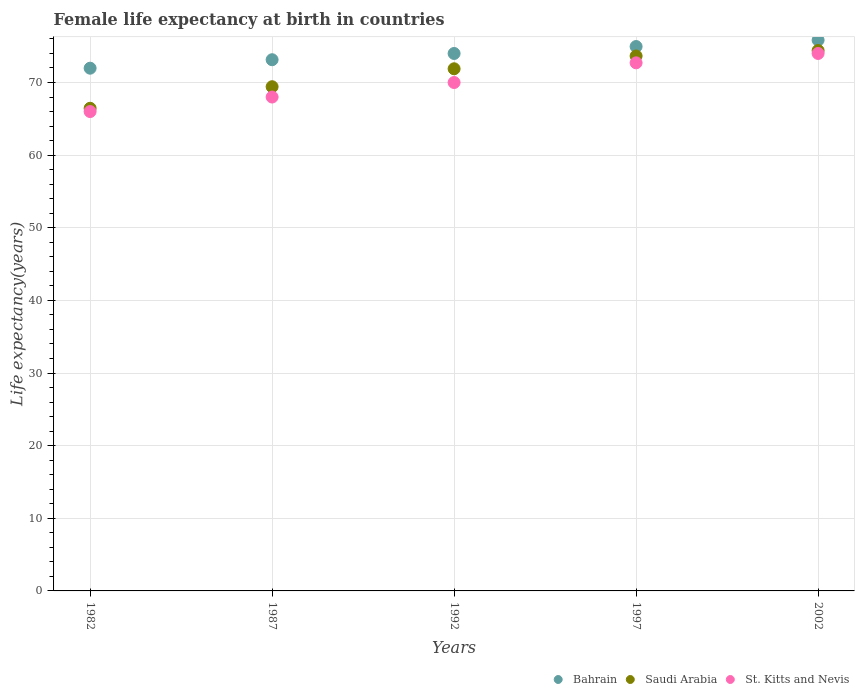How many different coloured dotlines are there?
Your answer should be compact. 3. Is the number of dotlines equal to the number of legend labels?
Your answer should be very brief. Yes. What is the female life expectancy at birth in St. Kitts and Nevis in 1982?
Your answer should be compact. 66. Across all years, what is the maximum female life expectancy at birth in Saudi Arabia?
Give a very brief answer. 74.41. Across all years, what is the minimum female life expectancy at birth in Bahrain?
Ensure brevity in your answer.  71.97. In which year was the female life expectancy at birth in Saudi Arabia minimum?
Your answer should be very brief. 1982. What is the total female life expectancy at birth in Saudi Arabia in the graph?
Provide a succinct answer. 355.82. What is the difference between the female life expectancy at birth in St. Kitts and Nevis in 1982 and that in 2002?
Provide a short and direct response. -8. What is the difference between the female life expectancy at birth in Bahrain in 1997 and the female life expectancy at birth in St. Kitts and Nevis in 1987?
Your answer should be compact. 6.95. What is the average female life expectancy at birth in St. Kitts and Nevis per year?
Provide a succinct answer. 70.14. In the year 1982, what is the difference between the female life expectancy at birth in Bahrain and female life expectancy at birth in St. Kitts and Nevis?
Your response must be concise. 5.97. In how many years, is the female life expectancy at birth in Bahrain greater than 52 years?
Your answer should be very brief. 5. What is the ratio of the female life expectancy at birth in Bahrain in 1982 to that in 1987?
Offer a terse response. 0.98. Is the difference between the female life expectancy at birth in Bahrain in 1992 and 1997 greater than the difference between the female life expectancy at birth in St. Kitts and Nevis in 1992 and 1997?
Make the answer very short. Yes. What is the difference between the highest and the second highest female life expectancy at birth in St. Kitts and Nevis?
Your answer should be very brief. 1.29. What is the difference between the highest and the lowest female life expectancy at birth in Bahrain?
Provide a short and direct response. 3.86. Is the sum of the female life expectancy at birth in St. Kitts and Nevis in 1992 and 2002 greater than the maximum female life expectancy at birth in Saudi Arabia across all years?
Offer a terse response. Yes. Is it the case that in every year, the sum of the female life expectancy at birth in Bahrain and female life expectancy at birth in Saudi Arabia  is greater than the female life expectancy at birth in St. Kitts and Nevis?
Keep it short and to the point. Yes. Does the female life expectancy at birth in Bahrain monotonically increase over the years?
Give a very brief answer. Yes. What is the difference between two consecutive major ticks on the Y-axis?
Your answer should be very brief. 10. Are the values on the major ticks of Y-axis written in scientific E-notation?
Your answer should be compact. No. Does the graph contain any zero values?
Ensure brevity in your answer.  No. Where does the legend appear in the graph?
Offer a very short reply. Bottom right. What is the title of the graph?
Make the answer very short. Female life expectancy at birth in countries. What is the label or title of the Y-axis?
Provide a succinct answer. Life expectancy(years). What is the Life expectancy(years) of Bahrain in 1982?
Ensure brevity in your answer.  71.97. What is the Life expectancy(years) of Saudi Arabia in 1982?
Provide a short and direct response. 66.45. What is the Life expectancy(years) in St. Kitts and Nevis in 1982?
Offer a very short reply. 66. What is the Life expectancy(years) in Bahrain in 1987?
Offer a very short reply. 73.14. What is the Life expectancy(years) of Saudi Arabia in 1987?
Your response must be concise. 69.42. What is the Life expectancy(years) in Bahrain in 1992?
Your answer should be compact. 74. What is the Life expectancy(years) in Saudi Arabia in 1992?
Your answer should be very brief. 71.89. What is the Life expectancy(years) of Bahrain in 1997?
Offer a very short reply. 74.95. What is the Life expectancy(years) of Saudi Arabia in 1997?
Provide a succinct answer. 73.65. What is the Life expectancy(years) of St. Kitts and Nevis in 1997?
Provide a short and direct response. 72.71. What is the Life expectancy(years) of Bahrain in 2002?
Your response must be concise. 75.83. What is the Life expectancy(years) of Saudi Arabia in 2002?
Ensure brevity in your answer.  74.41. What is the Life expectancy(years) of St. Kitts and Nevis in 2002?
Your response must be concise. 74. Across all years, what is the maximum Life expectancy(years) in Bahrain?
Your answer should be very brief. 75.83. Across all years, what is the maximum Life expectancy(years) in Saudi Arabia?
Give a very brief answer. 74.41. Across all years, what is the maximum Life expectancy(years) in St. Kitts and Nevis?
Your answer should be compact. 74. Across all years, what is the minimum Life expectancy(years) in Bahrain?
Your response must be concise. 71.97. Across all years, what is the minimum Life expectancy(years) in Saudi Arabia?
Offer a very short reply. 66.45. What is the total Life expectancy(years) in Bahrain in the graph?
Ensure brevity in your answer.  369.89. What is the total Life expectancy(years) in Saudi Arabia in the graph?
Offer a terse response. 355.82. What is the total Life expectancy(years) in St. Kitts and Nevis in the graph?
Your answer should be compact. 350.71. What is the difference between the Life expectancy(years) of Bahrain in 1982 and that in 1987?
Give a very brief answer. -1.17. What is the difference between the Life expectancy(years) in Saudi Arabia in 1982 and that in 1987?
Provide a short and direct response. -2.97. What is the difference between the Life expectancy(years) of St. Kitts and Nevis in 1982 and that in 1987?
Provide a succinct answer. -2. What is the difference between the Life expectancy(years) of Bahrain in 1982 and that in 1992?
Provide a short and direct response. -2.03. What is the difference between the Life expectancy(years) of Saudi Arabia in 1982 and that in 1992?
Ensure brevity in your answer.  -5.44. What is the difference between the Life expectancy(years) of Bahrain in 1982 and that in 1997?
Provide a short and direct response. -2.98. What is the difference between the Life expectancy(years) in Saudi Arabia in 1982 and that in 1997?
Give a very brief answer. -7.2. What is the difference between the Life expectancy(years) in St. Kitts and Nevis in 1982 and that in 1997?
Your answer should be compact. -6.71. What is the difference between the Life expectancy(years) in Bahrain in 1982 and that in 2002?
Make the answer very short. -3.86. What is the difference between the Life expectancy(years) in Saudi Arabia in 1982 and that in 2002?
Offer a very short reply. -7.95. What is the difference between the Life expectancy(years) in St. Kitts and Nevis in 1982 and that in 2002?
Make the answer very short. -8. What is the difference between the Life expectancy(years) in Bahrain in 1987 and that in 1992?
Provide a succinct answer. -0.86. What is the difference between the Life expectancy(years) in Saudi Arabia in 1987 and that in 1992?
Ensure brevity in your answer.  -2.47. What is the difference between the Life expectancy(years) of Bahrain in 1987 and that in 1997?
Offer a very short reply. -1.82. What is the difference between the Life expectancy(years) of Saudi Arabia in 1987 and that in 1997?
Your answer should be compact. -4.23. What is the difference between the Life expectancy(years) of St. Kitts and Nevis in 1987 and that in 1997?
Ensure brevity in your answer.  -4.71. What is the difference between the Life expectancy(years) of Bahrain in 1987 and that in 2002?
Your answer should be compact. -2.7. What is the difference between the Life expectancy(years) of Saudi Arabia in 1987 and that in 2002?
Offer a terse response. -4.99. What is the difference between the Life expectancy(years) in St. Kitts and Nevis in 1987 and that in 2002?
Give a very brief answer. -6. What is the difference between the Life expectancy(years) of Bahrain in 1992 and that in 1997?
Provide a short and direct response. -0.96. What is the difference between the Life expectancy(years) in Saudi Arabia in 1992 and that in 1997?
Make the answer very short. -1.76. What is the difference between the Life expectancy(years) in St. Kitts and Nevis in 1992 and that in 1997?
Your response must be concise. -2.71. What is the difference between the Life expectancy(years) of Bahrain in 1992 and that in 2002?
Keep it short and to the point. -1.84. What is the difference between the Life expectancy(years) in Saudi Arabia in 1992 and that in 2002?
Make the answer very short. -2.52. What is the difference between the Life expectancy(years) in St. Kitts and Nevis in 1992 and that in 2002?
Offer a terse response. -4. What is the difference between the Life expectancy(years) in Bahrain in 1997 and that in 2002?
Your response must be concise. -0.88. What is the difference between the Life expectancy(years) of Saudi Arabia in 1997 and that in 2002?
Provide a succinct answer. -0.75. What is the difference between the Life expectancy(years) in St. Kitts and Nevis in 1997 and that in 2002?
Offer a very short reply. -1.29. What is the difference between the Life expectancy(years) in Bahrain in 1982 and the Life expectancy(years) in Saudi Arabia in 1987?
Provide a succinct answer. 2.55. What is the difference between the Life expectancy(years) of Bahrain in 1982 and the Life expectancy(years) of St. Kitts and Nevis in 1987?
Offer a very short reply. 3.97. What is the difference between the Life expectancy(years) of Saudi Arabia in 1982 and the Life expectancy(years) of St. Kitts and Nevis in 1987?
Make the answer very short. -1.55. What is the difference between the Life expectancy(years) in Bahrain in 1982 and the Life expectancy(years) in Saudi Arabia in 1992?
Your response must be concise. 0.08. What is the difference between the Life expectancy(years) in Bahrain in 1982 and the Life expectancy(years) in St. Kitts and Nevis in 1992?
Offer a very short reply. 1.97. What is the difference between the Life expectancy(years) of Saudi Arabia in 1982 and the Life expectancy(years) of St. Kitts and Nevis in 1992?
Offer a terse response. -3.55. What is the difference between the Life expectancy(years) of Bahrain in 1982 and the Life expectancy(years) of Saudi Arabia in 1997?
Provide a succinct answer. -1.68. What is the difference between the Life expectancy(years) of Bahrain in 1982 and the Life expectancy(years) of St. Kitts and Nevis in 1997?
Give a very brief answer. -0.74. What is the difference between the Life expectancy(years) in Saudi Arabia in 1982 and the Life expectancy(years) in St. Kitts and Nevis in 1997?
Offer a terse response. -6.26. What is the difference between the Life expectancy(years) in Bahrain in 1982 and the Life expectancy(years) in Saudi Arabia in 2002?
Your answer should be compact. -2.44. What is the difference between the Life expectancy(years) in Bahrain in 1982 and the Life expectancy(years) in St. Kitts and Nevis in 2002?
Provide a short and direct response. -2.03. What is the difference between the Life expectancy(years) in Saudi Arabia in 1982 and the Life expectancy(years) in St. Kitts and Nevis in 2002?
Offer a terse response. -7.55. What is the difference between the Life expectancy(years) in Bahrain in 1987 and the Life expectancy(years) in Saudi Arabia in 1992?
Provide a succinct answer. 1.25. What is the difference between the Life expectancy(years) of Bahrain in 1987 and the Life expectancy(years) of St. Kitts and Nevis in 1992?
Offer a terse response. 3.14. What is the difference between the Life expectancy(years) in Saudi Arabia in 1987 and the Life expectancy(years) in St. Kitts and Nevis in 1992?
Provide a short and direct response. -0.58. What is the difference between the Life expectancy(years) in Bahrain in 1987 and the Life expectancy(years) in Saudi Arabia in 1997?
Offer a very short reply. -0.52. What is the difference between the Life expectancy(years) of Bahrain in 1987 and the Life expectancy(years) of St. Kitts and Nevis in 1997?
Ensure brevity in your answer.  0.43. What is the difference between the Life expectancy(years) of Saudi Arabia in 1987 and the Life expectancy(years) of St. Kitts and Nevis in 1997?
Provide a succinct answer. -3.29. What is the difference between the Life expectancy(years) in Bahrain in 1987 and the Life expectancy(years) in Saudi Arabia in 2002?
Your answer should be very brief. -1.27. What is the difference between the Life expectancy(years) in Bahrain in 1987 and the Life expectancy(years) in St. Kitts and Nevis in 2002?
Make the answer very short. -0.86. What is the difference between the Life expectancy(years) of Saudi Arabia in 1987 and the Life expectancy(years) of St. Kitts and Nevis in 2002?
Offer a very short reply. -4.58. What is the difference between the Life expectancy(years) of Bahrain in 1992 and the Life expectancy(years) of Saudi Arabia in 1997?
Make the answer very short. 0.34. What is the difference between the Life expectancy(years) in Bahrain in 1992 and the Life expectancy(years) in St. Kitts and Nevis in 1997?
Give a very brief answer. 1.29. What is the difference between the Life expectancy(years) in Saudi Arabia in 1992 and the Life expectancy(years) in St. Kitts and Nevis in 1997?
Your response must be concise. -0.82. What is the difference between the Life expectancy(years) of Bahrain in 1992 and the Life expectancy(years) of Saudi Arabia in 2002?
Provide a short and direct response. -0.41. What is the difference between the Life expectancy(years) of Bahrain in 1992 and the Life expectancy(years) of St. Kitts and Nevis in 2002?
Your answer should be very brief. -0. What is the difference between the Life expectancy(years) in Saudi Arabia in 1992 and the Life expectancy(years) in St. Kitts and Nevis in 2002?
Provide a succinct answer. -2.11. What is the difference between the Life expectancy(years) in Bahrain in 1997 and the Life expectancy(years) in Saudi Arabia in 2002?
Offer a terse response. 0.55. What is the difference between the Life expectancy(years) in Bahrain in 1997 and the Life expectancy(years) in St. Kitts and Nevis in 2002?
Give a very brief answer. 0.95. What is the difference between the Life expectancy(years) of Saudi Arabia in 1997 and the Life expectancy(years) of St. Kitts and Nevis in 2002?
Offer a very short reply. -0.35. What is the average Life expectancy(years) in Bahrain per year?
Your answer should be compact. 73.98. What is the average Life expectancy(years) in Saudi Arabia per year?
Ensure brevity in your answer.  71.16. What is the average Life expectancy(years) of St. Kitts and Nevis per year?
Make the answer very short. 70.14. In the year 1982, what is the difference between the Life expectancy(years) in Bahrain and Life expectancy(years) in Saudi Arabia?
Keep it short and to the point. 5.52. In the year 1982, what is the difference between the Life expectancy(years) in Bahrain and Life expectancy(years) in St. Kitts and Nevis?
Make the answer very short. 5.97. In the year 1982, what is the difference between the Life expectancy(years) of Saudi Arabia and Life expectancy(years) of St. Kitts and Nevis?
Give a very brief answer. 0.45. In the year 1987, what is the difference between the Life expectancy(years) of Bahrain and Life expectancy(years) of Saudi Arabia?
Provide a succinct answer. 3.72. In the year 1987, what is the difference between the Life expectancy(years) in Bahrain and Life expectancy(years) in St. Kitts and Nevis?
Make the answer very short. 5.14. In the year 1987, what is the difference between the Life expectancy(years) of Saudi Arabia and Life expectancy(years) of St. Kitts and Nevis?
Your answer should be very brief. 1.42. In the year 1992, what is the difference between the Life expectancy(years) of Bahrain and Life expectancy(years) of Saudi Arabia?
Provide a short and direct response. 2.11. In the year 1992, what is the difference between the Life expectancy(years) of Bahrain and Life expectancy(years) of St. Kitts and Nevis?
Offer a very short reply. 4. In the year 1992, what is the difference between the Life expectancy(years) in Saudi Arabia and Life expectancy(years) in St. Kitts and Nevis?
Offer a terse response. 1.89. In the year 1997, what is the difference between the Life expectancy(years) of Bahrain and Life expectancy(years) of Saudi Arabia?
Keep it short and to the point. 1.3. In the year 1997, what is the difference between the Life expectancy(years) of Bahrain and Life expectancy(years) of St. Kitts and Nevis?
Your answer should be very brief. 2.24. In the year 1997, what is the difference between the Life expectancy(years) in Saudi Arabia and Life expectancy(years) in St. Kitts and Nevis?
Make the answer very short. 0.94. In the year 2002, what is the difference between the Life expectancy(years) of Bahrain and Life expectancy(years) of Saudi Arabia?
Provide a succinct answer. 1.43. In the year 2002, what is the difference between the Life expectancy(years) of Bahrain and Life expectancy(years) of St. Kitts and Nevis?
Keep it short and to the point. 1.83. In the year 2002, what is the difference between the Life expectancy(years) in Saudi Arabia and Life expectancy(years) in St. Kitts and Nevis?
Make the answer very short. 0.41. What is the ratio of the Life expectancy(years) of Bahrain in 1982 to that in 1987?
Your response must be concise. 0.98. What is the ratio of the Life expectancy(years) of Saudi Arabia in 1982 to that in 1987?
Provide a succinct answer. 0.96. What is the ratio of the Life expectancy(years) of St. Kitts and Nevis in 1982 to that in 1987?
Your answer should be compact. 0.97. What is the ratio of the Life expectancy(years) of Bahrain in 1982 to that in 1992?
Keep it short and to the point. 0.97. What is the ratio of the Life expectancy(years) of Saudi Arabia in 1982 to that in 1992?
Provide a short and direct response. 0.92. What is the ratio of the Life expectancy(years) in St. Kitts and Nevis in 1982 to that in 1992?
Offer a terse response. 0.94. What is the ratio of the Life expectancy(years) of Bahrain in 1982 to that in 1997?
Provide a succinct answer. 0.96. What is the ratio of the Life expectancy(years) of Saudi Arabia in 1982 to that in 1997?
Provide a short and direct response. 0.9. What is the ratio of the Life expectancy(years) in St. Kitts and Nevis in 1982 to that in 1997?
Your answer should be compact. 0.91. What is the ratio of the Life expectancy(years) in Bahrain in 1982 to that in 2002?
Your answer should be compact. 0.95. What is the ratio of the Life expectancy(years) of Saudi Arabia in 1982 to that in 2002?
Ensure brevity in your answer.  0.89. What is the ratio of the Life expectancy(years) of St. Kitts and Nevis in 1982 to that in 2002?
Provide a short and direct response. 0.89. What is the ratio of the Life expectancy(years) of Bahrain in 1987 to that in 1992?
Ensure brevity in your answer.  0.99. What is the ratio of the Life expectancy(years) of Saudi Arabia in 1987 to that in 1992?
Give a very brief answer. 0.97. What is the ratio of the Life expectancy(years) in St. Kitts and Nevis in 1987 to that in 1992?
Provide a succinct answer. 0.97. What is the ratio of the Life expectancy(years) in Bahrain in 1987 to that in 1997?
Your answer should be very brief. 0.98. What is the ratio of the Life expectancy(years) of Saudi Arabia in 1987 to that in 1997?
Provide a short and direct response. 0.94. What is the ratio of the Life expectancy(years) of St. Kitts and Nevis in 1987 to that in 1997?
Your response must be concise. 0.94. What is the ratio of the Life expectancy(years) in Bahrain in 1987 to that in 2002?
Your answer should be very brief. 0.96. What is the ratio of the Life expectancy(years) in Saudi Arabia in 1987 to that in 2002?
Your answer should be very brief. 0.93. What is the ratio of the Life expectancy(years) in St. Kitts and Nevis in 1987 to that in 2002?
Keep it short and to the point. 0.92. What is the ratio of the Life expectancy(years) in Bahrain in 1992 to that in 1997?
Offer a terse response. 0.99. What is the ratio of the Life expectancy(years) in Saudi Arabia in 1992 to that in 1997?
Your answer should be very brief. 0.98. What is the ratio of the Life expectancy(years) of St. Kitts and Nevis in 1992 to that in 1997?
Give a very brief answer. 0.96. What is the ratio of the Life expectancy(years) of Bahrain in 1992 to that in 2002?
Give a very brief answer. 0.98. What is the ratio of the Life expectancy(years) of Saudi Arabia in 1992 to that in 2002?
Keep it short and to the point. 0.97. What is the ratio of the Life expectancy(years) in St. Kitts and Nevis in 1992 to that in 2002?
Offer a very short reply. 0.95. What is the ratio of the Life expectancy(years) in Bahrain in 1997 to that in 2002?
Make the answer very short. 0.99. What is the ratio of the Life expectancy(years) in St. Kitts and Nevis in 1997 to that in 2002?
Your answer should be compact. 0.98. What is the difference between the highest and the second highest Life expectancy(years) of Bahrain?
Your answer should be compact. 0.88. What is the difference between the highest and the second highest Life expectancy(years) in Saudi Arabia?
Your answer should be very brief. 0.75. What is the difference between the highest and the second highest Life expectancy(years) of St. Kitts and Nevis?
Ensure brevity in your answer.  1.29. What is the difference between the highest and the lowest Life expectancy(years) of Bahrain?
Provide a short and direct response. 3.86. What is the difference between the highest and the lowest Life expectancy(years) of Saudi Arabia?
Ensure brevity in your answer.  7.95. 